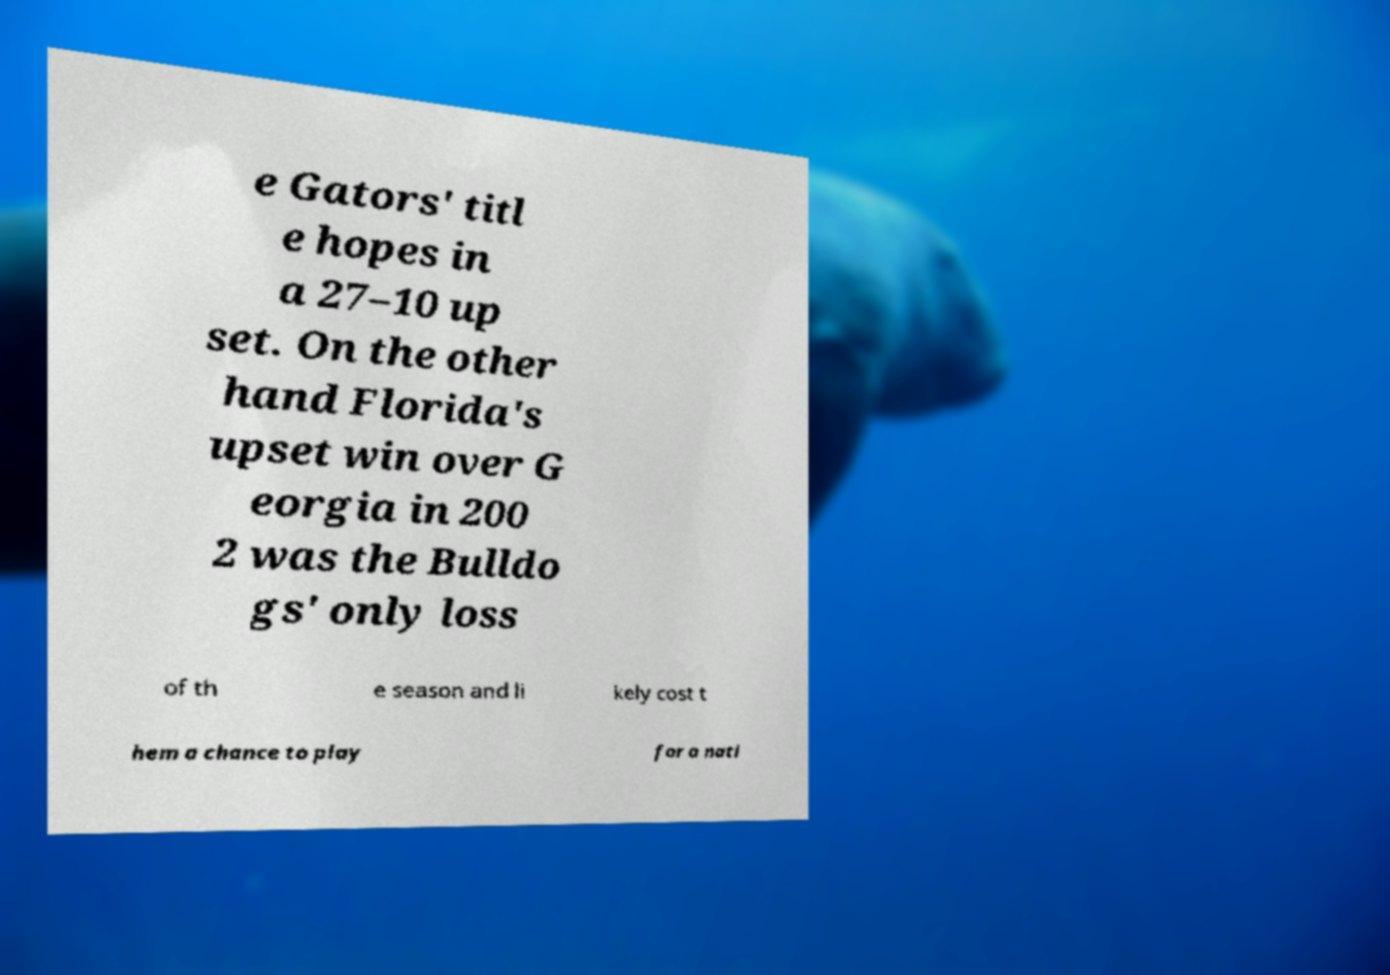There's text embedded in this image that I need extracted. Can you transcribe it verbatim? e Gators' titl e hopes in a 27–10 up set. On the other hand Florida's upset win over G eorgia in 200 2 was the Bulldo gs' only loss of th e season and li kely cost t hem a chance to play for a nati 